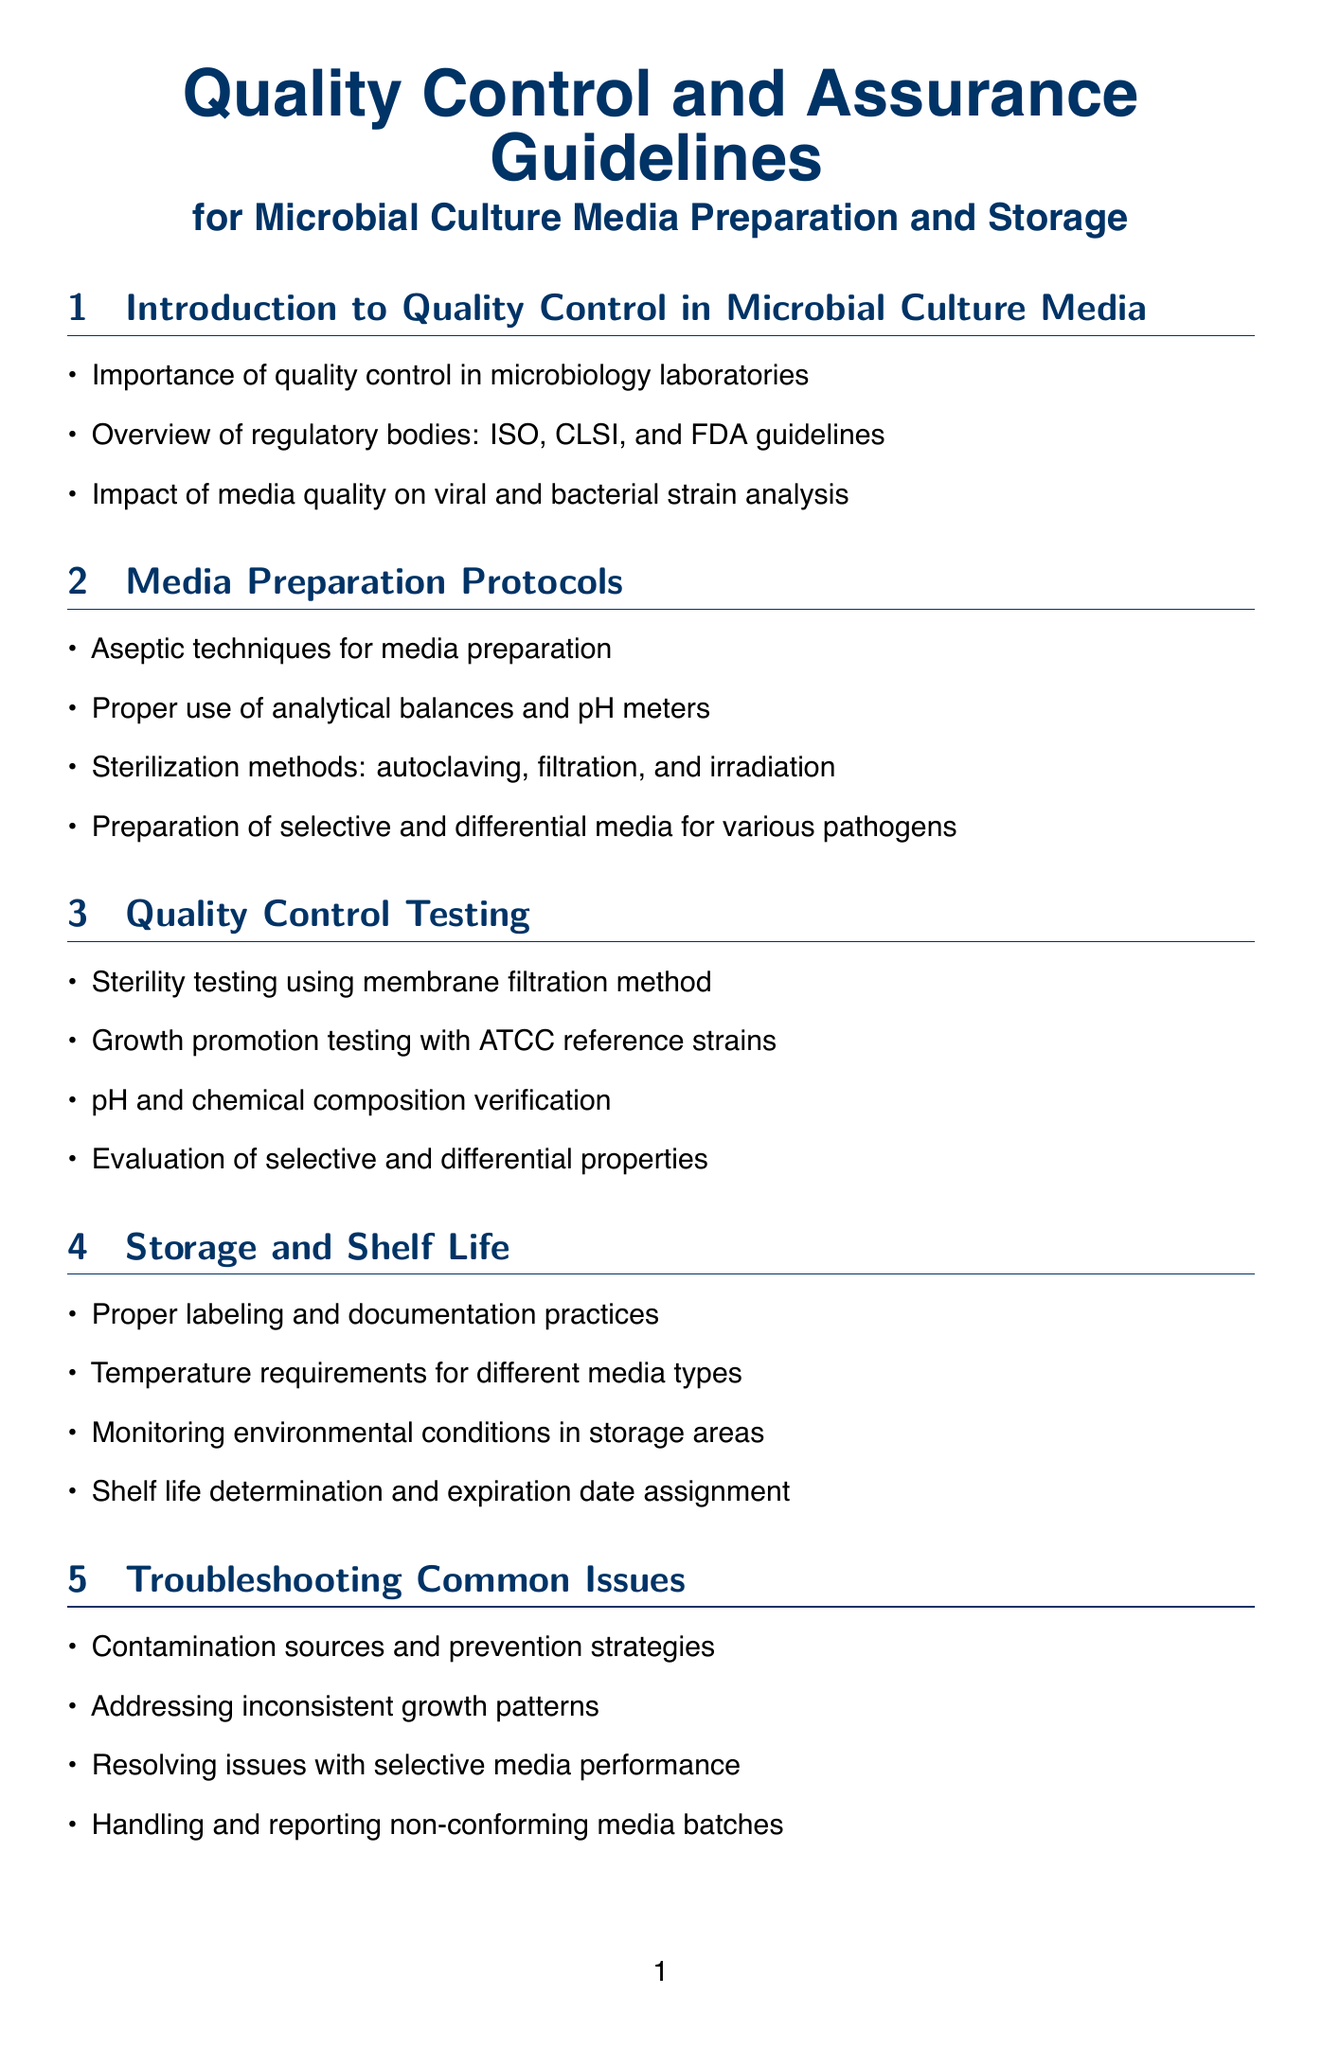What is the importance of quality control? The importance of quality control is highlighted in the introduction section of the document.
Answer: Importance of quality control in microbiology laboratories Which method is used for sterility testing? The document specifies the membrane filtration method for sterility testing in the quality control testing section.
Answer: Membrane filtration method What equipment is needed to maintain the pH level? The document mentions a specific piece of equipment used for measuring pH in the media preparation protocols section.
Answer: pH meter What type of strains are used for growth promotion testing? The growth promotion testing section indicates the type of reference strains utilized in the testing process.
Answer: ATCC reference strains What should be documented during media preparation? The documentation and record keeping section highlights key practices needed during media preparation.
Answer: Media preparation logs What are the temperature requirements for storage? The storage and shelf life section outlines specific conditions regarding media storage.
Answer: Temperature requirements for different media types Which regulatory body provides guidelines for microbial culture media? The introduction section lists regulatory bodies that provide guidelines related to quality control in microbiology.
Answer: FDA How is shelf life determined? The document explains the process of shelf life determination in the relevant section about storage and shelf life.
Answer: Shelf life determination and expiration date assignment What is a key regulation mentioned regarding media preparation? The key regulations section contains important guidelines applicable to culture media preparation.
Answer: ISO 11133:2014 